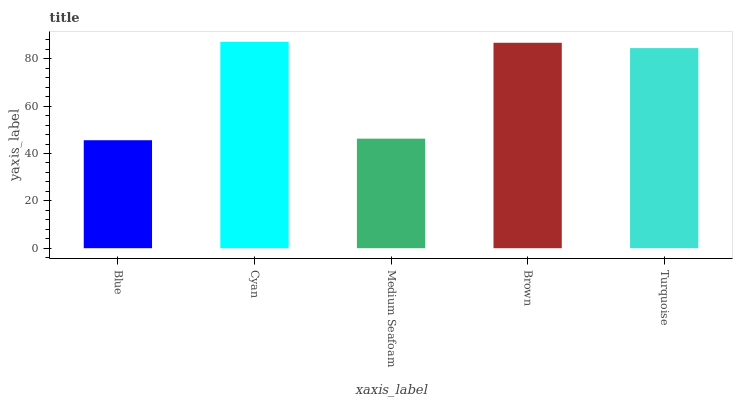Is Blue the minimum?
Answer yes or no. Yes. Is Cyan the maximum?
Answer yes or no. Yes. Is Medium Seafoam the minimum?
Answer yes or no. No. Is Medium Seafoam the maximum?
Answer yes or no. No. Is Cyan greater than Medium Seafoam?
Answer yes or no. Yes. Is Medium Seafoam less than Cyan?
Answer yes or no. Yes. Is Medium Seafoam greater than Cyan?
Answer yes or no. No. Is Cyan less than Medium Seafoam?
Answer yes or no. No. Is Turquoise the high median?
Answer yes or no. Yes. Is Turquoise the low median?
Answer yes or no. Yes. Is Cyan the high median?
Answer yes or no. No. Is Brown the low median?
Answer yes or no. No. 